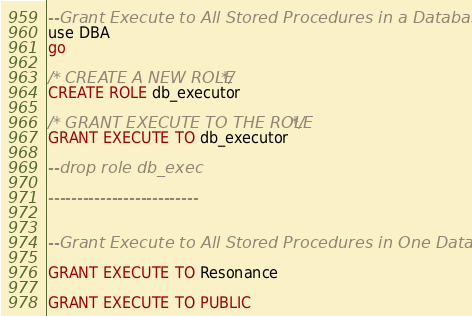Convert code to text. <code><loc_0><loc_0><loc_500><loc_500><_SQL_>--Grant Execute to All Stored Procedures in a Database
use DBA
go

/* CREATE A NEW ROLE */
CREATE ROLE db_executor

/* GRANT EXECUTE TO THE ROLE */
GRANT EXECUTE TO db_executor

--drop role db_exec

--------------------------


--Grant Execute to All Stored Procedures in One Database

GRANT EXECUTE TO Resonance

GRANT EXECUTE TO PUBLIC

</code> 